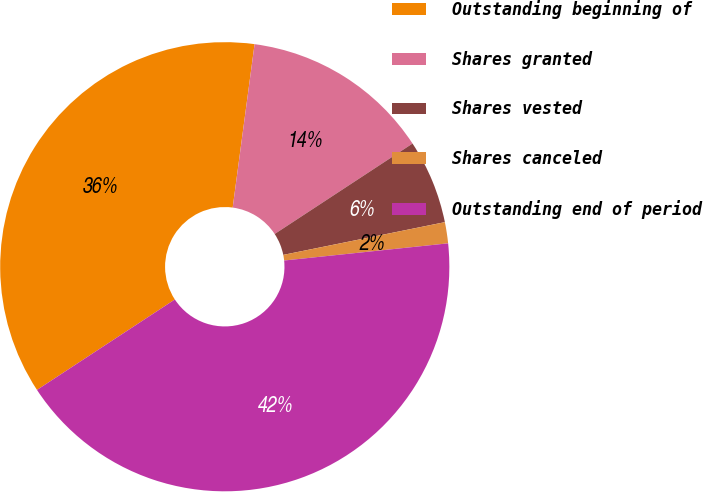Convert chart to OTSL. <chart><loc_0><loc_0><loc_500><loc_500><pie_chart><fcel>Outstanding beginning of<fcel>Shares granted<fcel>Shares vested<fcel>Shares canceled<fcel>Outstanding end of period<nl><fcel>36.36%<fcel>13.64%<fcel>6.06%<fcel>1.52%<fcel>42.42%<nl></chart> 